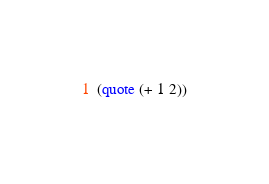<code> <loc_0><loc_0><loc_500><loc_500><_Scheme_>(quote (+ 1 2))
</code> 